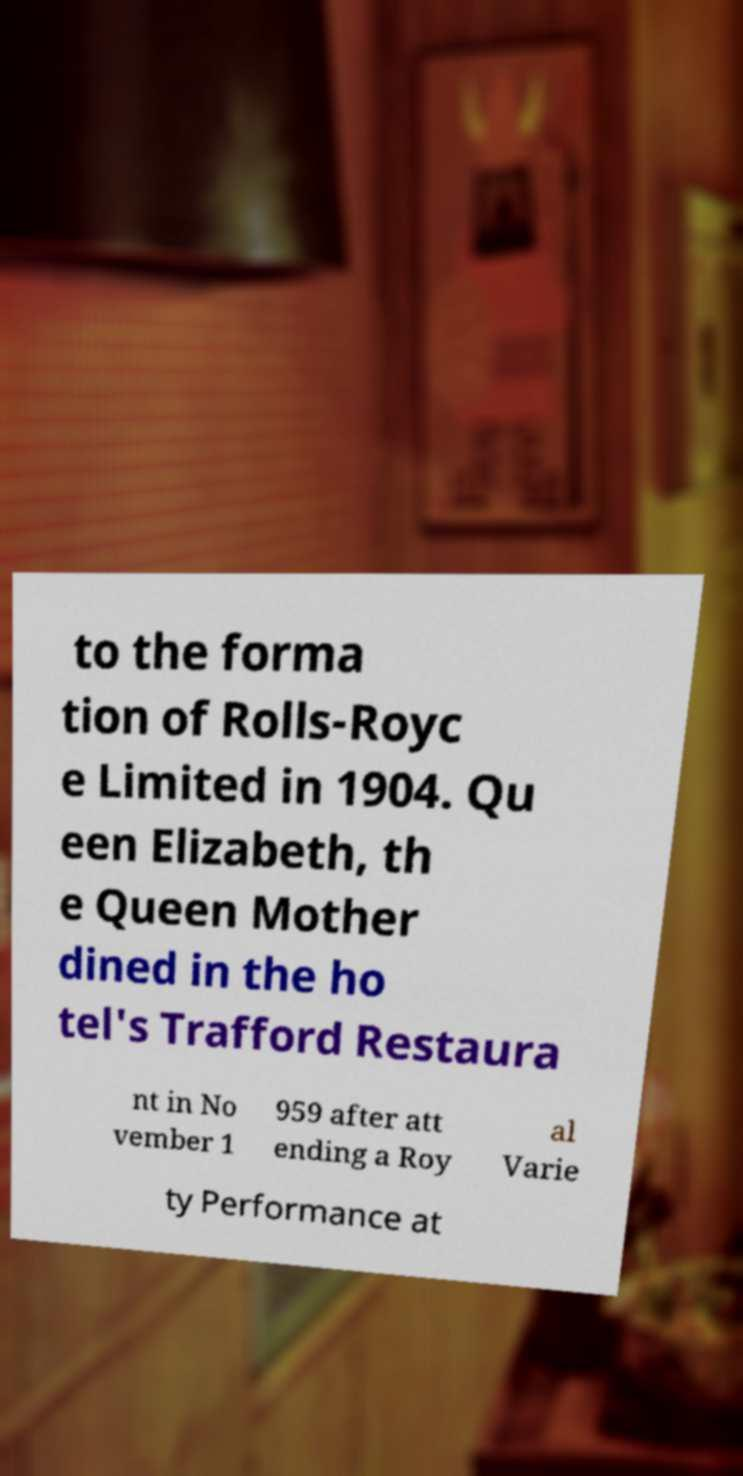Could you extract and type out the text from this image? to the forma tion of Rolls-Royc e Limited in 1904. Qu een Elizabeth, th e Queen Mother dined in the ho tel's Trafford Restaura nt in No vember 1 959 after att ending a Roy al Varie ty Performance at 